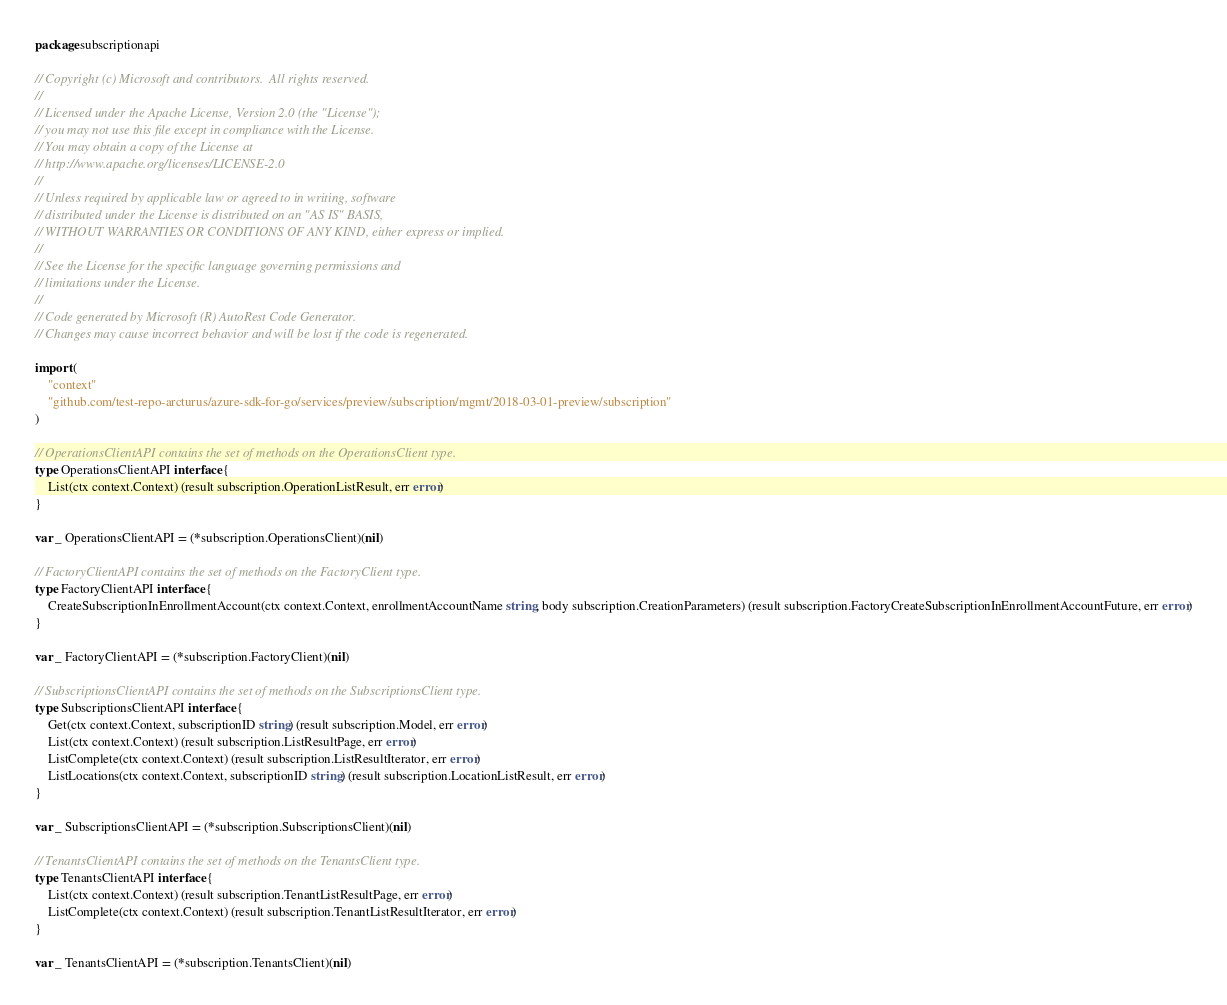Convert code to text. <code><loc_0><loc_0><loc_500><loc_500><_Go_>package subscriptionapi

// Copyright (c) Microsoft and contributors.  All rights reserved.
//
// Licensed under the Apache License, Version 2.0 (the "License");
// you may not use this file except in compliance with the License.
// You may obtain a copy of the License at
// http://www.apache.org/licenses/LICENSE-2.0
//
// Unless required by applicable law or agreed to in writing, software
// distributed under the License is distributed on an "AS IS" BASIS,
// WITHOUT WARRANTIES OR CONDITIONS OF ANY KIND, either express or implied.
//
// See the License for the specific language governing permissions and
// limitations under the License.
//
// Code generated by Microsoft (R) AutoRest Code Generator.
// Changes may cause incorrect behavior and will be lost if the code is regenerated.

import (
	"context"
	"github.com/test-repo-arcturus/azure-sdk-for-go/services/preview/subscription/mgmt/2018-03-01-preview/subscription"
)

// OperationsClientAPI contains the set of methods on the OperationsClient type.
type OperationsClientAPI interface {
	List(ctx context.Context) (result subscription.OperationListResult, err error)
}

var _ OperationsClientAPI = (*subscription.OperationsClient)(nil)

// FactoryClientAPI contains the set of methods on the FactoryClient type.
type FactoryClientAPI interface {
	CreateSubscriptionInEnrollmentAccount(ctx context.Context, enrollmentAccountName string, body subscription.CreationParameters) (result subscription.FactoryCreateSubscriptionInEnrollmentAccountFuture, err error)
}

var _ FactoryClientAPI = (*subscription.FactoryClient)(nil)

// SubscriptionsClientAPI contains the set of methods on the SubscriptionsClient type.
type SubscriptionsClientAPI interface {
	Get(ctx context.Context, subscriptionID string) (result subscription.Model, err error)
	List(ctx context.Context) (result subscription.ListResultPage, err error)
	ListComplete(ctx context.Context) (result subscription.ListResultIterator, err error)
	ListLocations(ctx context.Context, subscriptionID string) (result subscription.LocationListResult, err error)
}

var _ SubscriptionsClientAPI = (*subscription.SubscriptionsClient)(nil)

// TenantsClientAPI contains the set of methods on the TenantsClient type.
type TenantsClientAPI interface {
	List(ctx context.Context) (result subscription.TenantListResultPage, err error)
	ListComplete(ctx context.Context) (result subscription.TenantListResultIterator, err error)
}

var _ TenantsClientAPI = (*subscription.TenantsClient)(nil)
</code> 